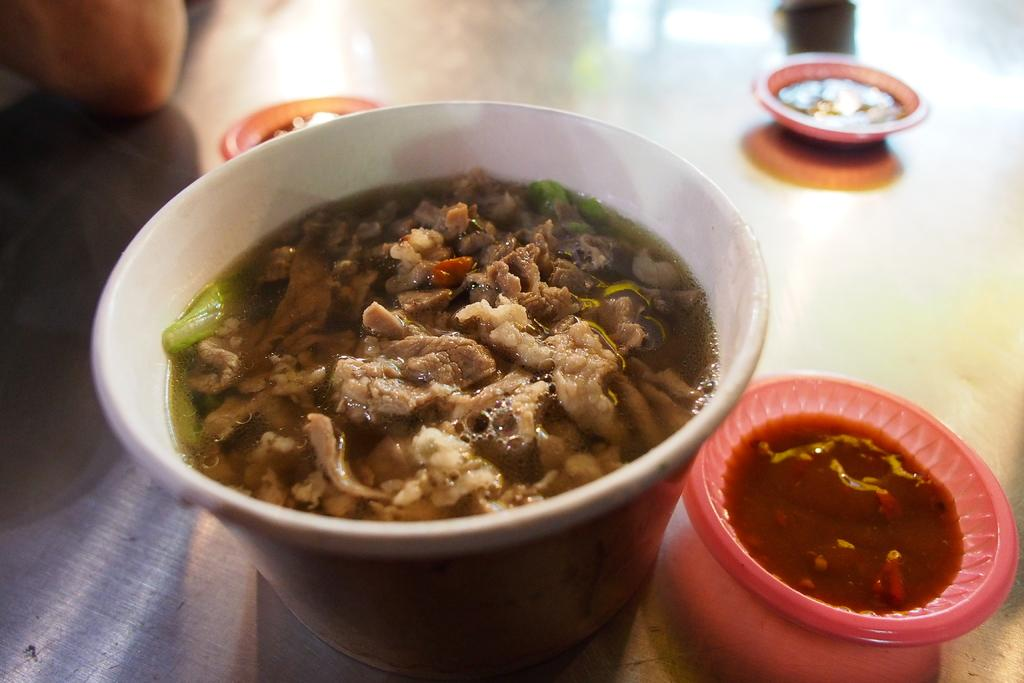What is the main piece of furniture in the image? There is a table in the image. What is placed on the table? There is a white color bowl on the table. What is inside the white bowl? The white bowl contains meat and soup. How many small bowls are on the table? There are three small bowls on the table. What is in the small bowls? The small bowls contain soup. Where is the hen sitting in the image? There is no hen present in the image. How many babies are visible in the image? There are no babies present in the image. 